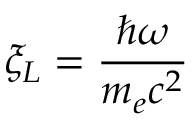Convert formula to latex. <formula><loc_0><loc_0><loc_500><loc_500>\xi _ { L } = \frac { \hbar { \omega } } { m _ { e } c ^ { 2 } }</formula> 